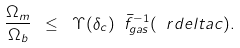<formula> <loc_0><loc_0><loc_500><loc_500>\frac { \Omega _ { m } } { \Omega _ { b } } \ \leq \ \Upsilon ( \delta _ { c } ) \ \bar { f } ^ { - 1 } _ { g a s } ( \ r d e l t a c ) .</formula> 